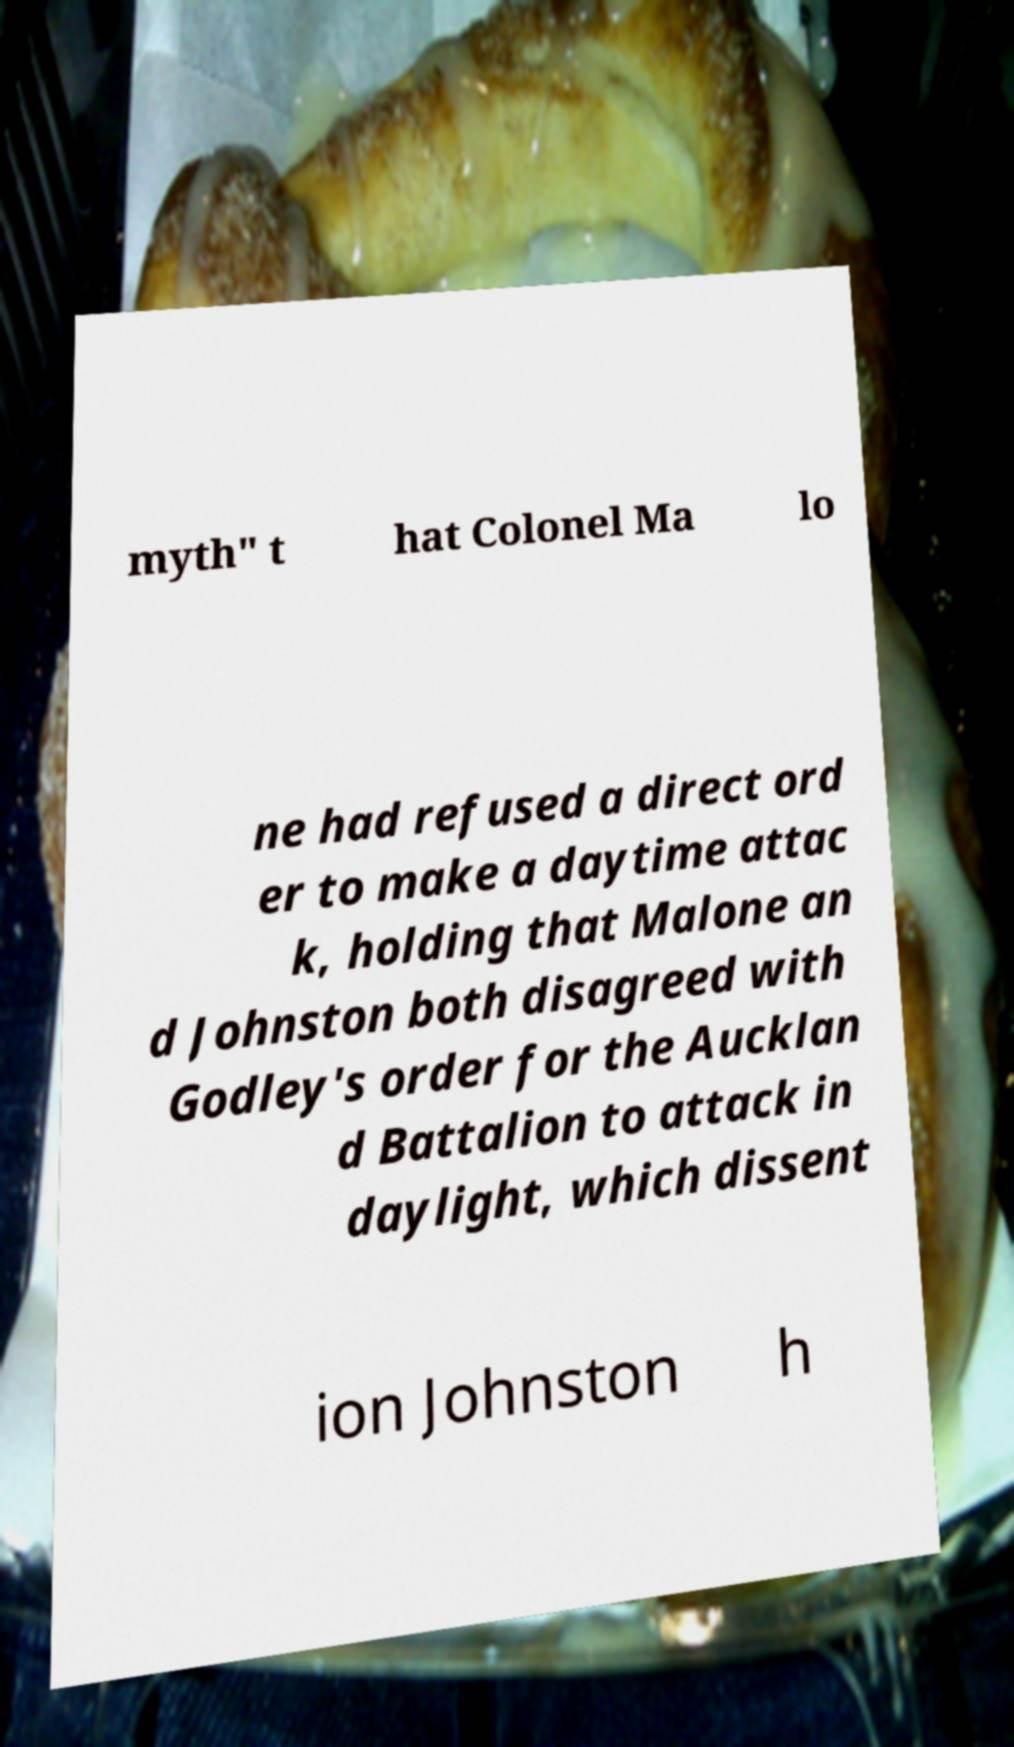What messages or text are displayed in this image? I need them in a readable, typed format. myth" t hat Colonel Ma lo ne had refused a direct ord er to make a daytime attac k, holding that Malone an d Johnston both disagreed with Godley's order for the Aucklan d Battalion to attack in daylight, which dissent ion Johnston h 